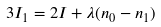<formula> <loc_0><loc_0><loc_500><loc_500>3 I _ { 1 } = 2 I + \lambda ( n _ { 0 } - n _ { 1 } )</formula> 